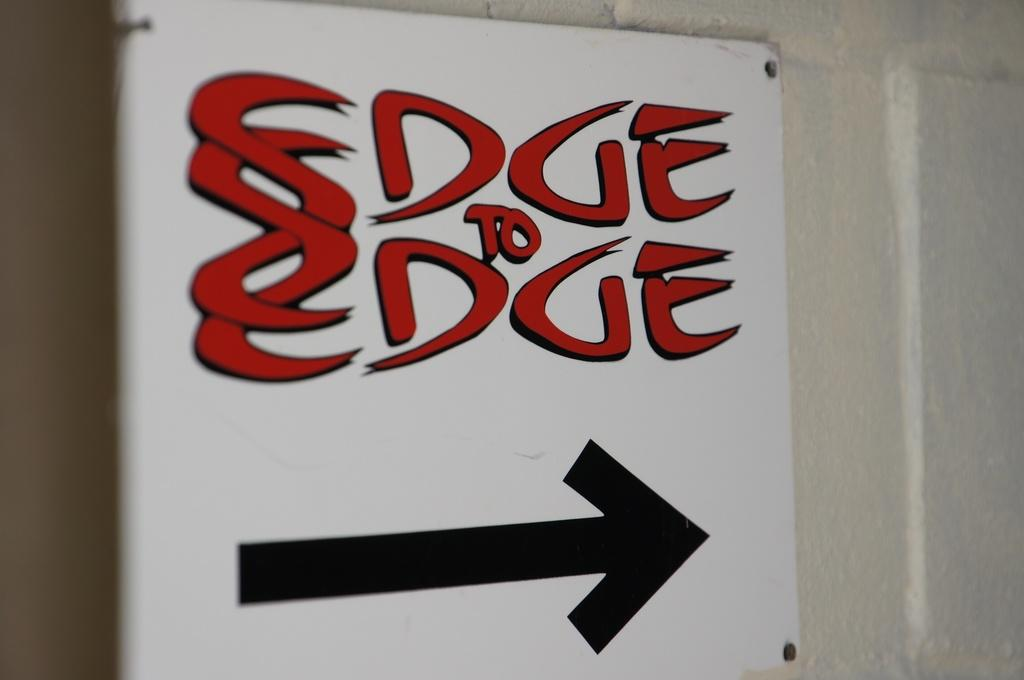<image>
Describe the image concisely. A black arrow below the red writing saying edge to edge. 